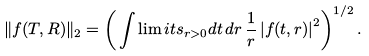<formula> <loc_0><loc_0><loc_500><loc_500>\| f ( T , R ) \| _ { 2 } = \left ( \, \int \lim i t s _ { r > 0 } d t \, d r \, \frac { 1 } { r } \left | f ( t , r ) \right | ^ { 2 } \right ) ^ { 1 / 2 } .</formula> 